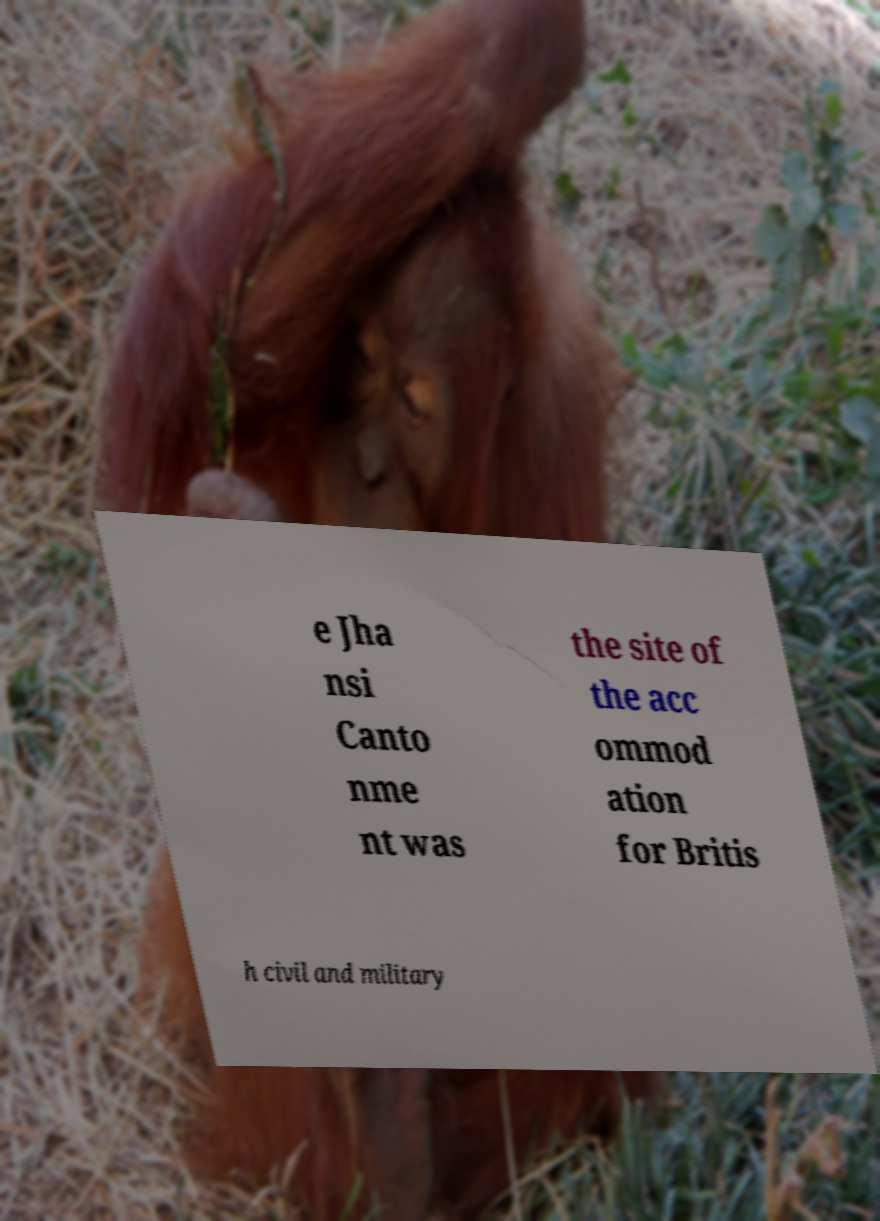For documentation purposes, I need the text within this image transcribed. Could you provide that? e Jha nsi Canto nme nt was the site of the acc ommod ation for Britis h civil and military 